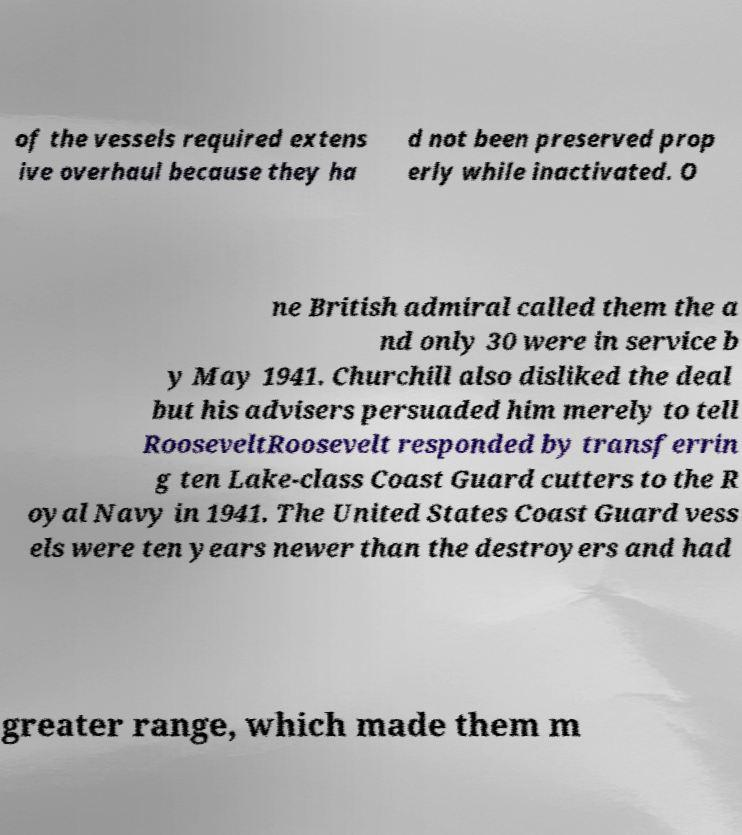Please read and relay the text visible in this image. What does it say? of the vessels required extens ive overhaul because they ha d not been preserved prop erly while inactivated. O ne British admiral called them the a nd only 30 were in service b y May 1941. Churchill also disliked the deal but his advisers persuaded him merely to tell RooseveltRoosevelt responded by transferrin g ten Lake-class Coast Guard cutters to the R oyal Navy in 1941. The United States Coast Guard vess els were ten years newer than the destroyers and had greater range, which made them m 